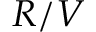<formula> <loc_0><loc_0><loc_500><loc_500>R / V</formula> 